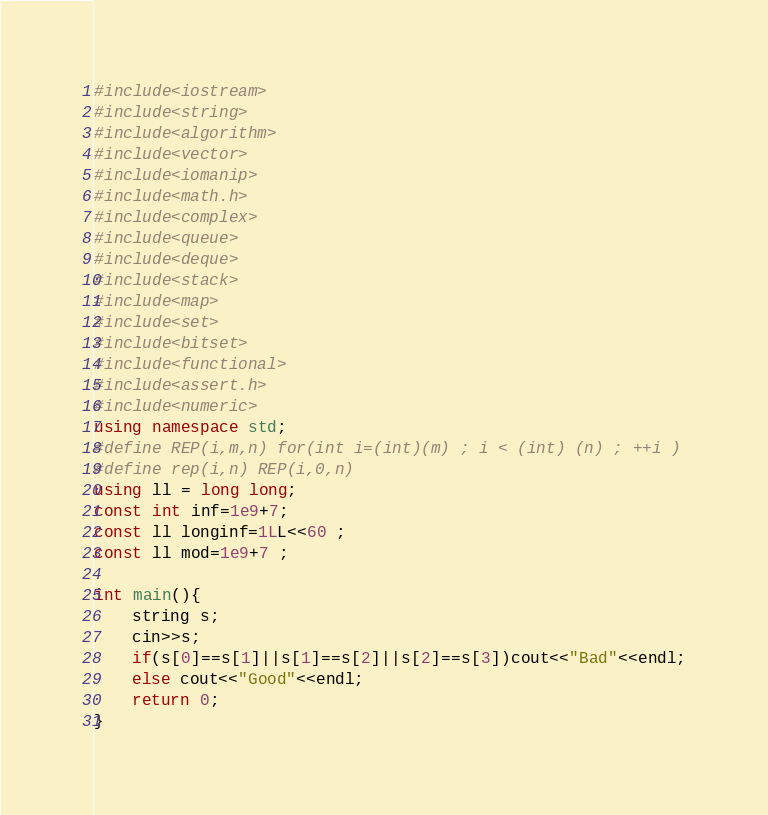<code> <loc_0><loc_0><loc_500><loc_500><_C++_>#include<iostream>
#include<string>
#include<algorithm>
#include<vector>
#include<iomanip>
#include<math.h>
#include<complex>
#include<queue>
#include<deque>
#include<stack>
#include<map>
#include<set>
#include<bitset>
#include<functional>
#include<assert.h>
#include<numeric>
using namespace std;
#define REP(i,m,n) for(int i=(int)(m) ; i < (int) (n) ; ++i )
#define rep(i,n) REP(i,0,n)
using ll = long long;
const int inf=1e9+7;
const ll longinf=1LL<<60 ;
const ll mod=1e9+7 ;

int main(){
    string s;
    cin>>s;
    if(s[0]==s[1]||s[1]==s[2]||s[2]==s[3])cout<<"Bad"<<endl;
    else cout<<"Good"<<endl;
    return 0;
}</code> 